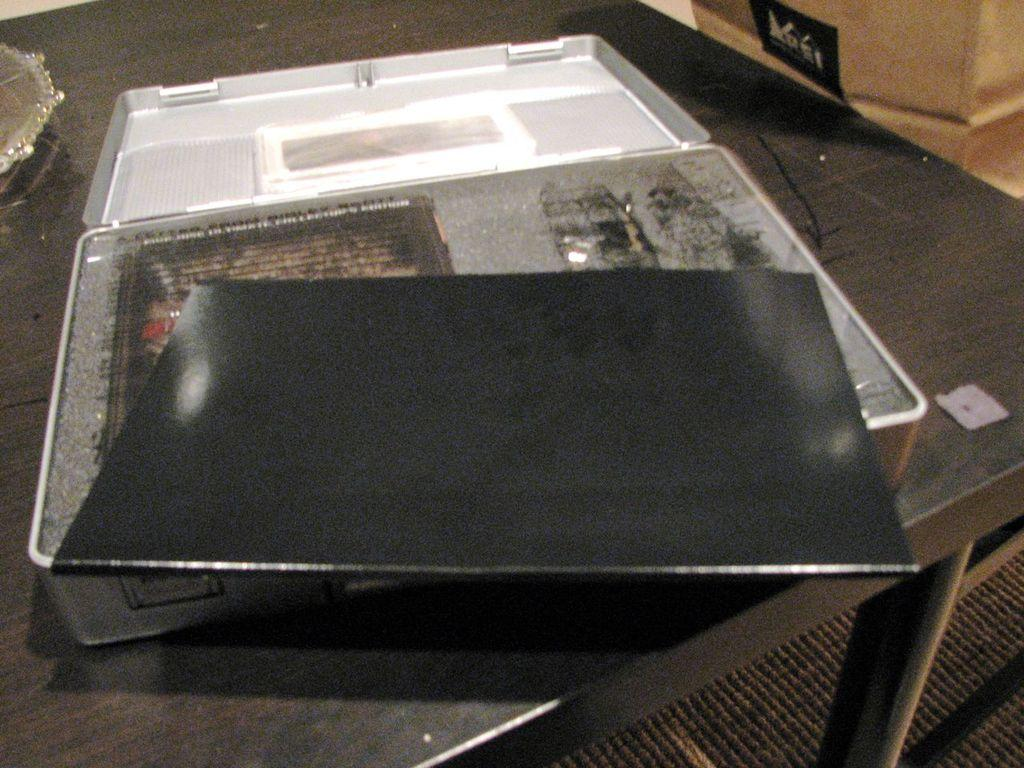What object is placed on the table in the image? There is a suitcase on the table. What can be found inside the suitcase? A laptop and a book are visible inside the suitcase. Can you describe any architectural features in the image? There is a pillar in the top right corner of the image. What type of flooring is present in the image? There is a carpet at the bottom of the image. What page is the cook reading from in the image? There is no cook or page present in the image. How many edges can be seen on the laptop in the image? The laptop is inside the suitcase, and its edges are not visible in the image. 